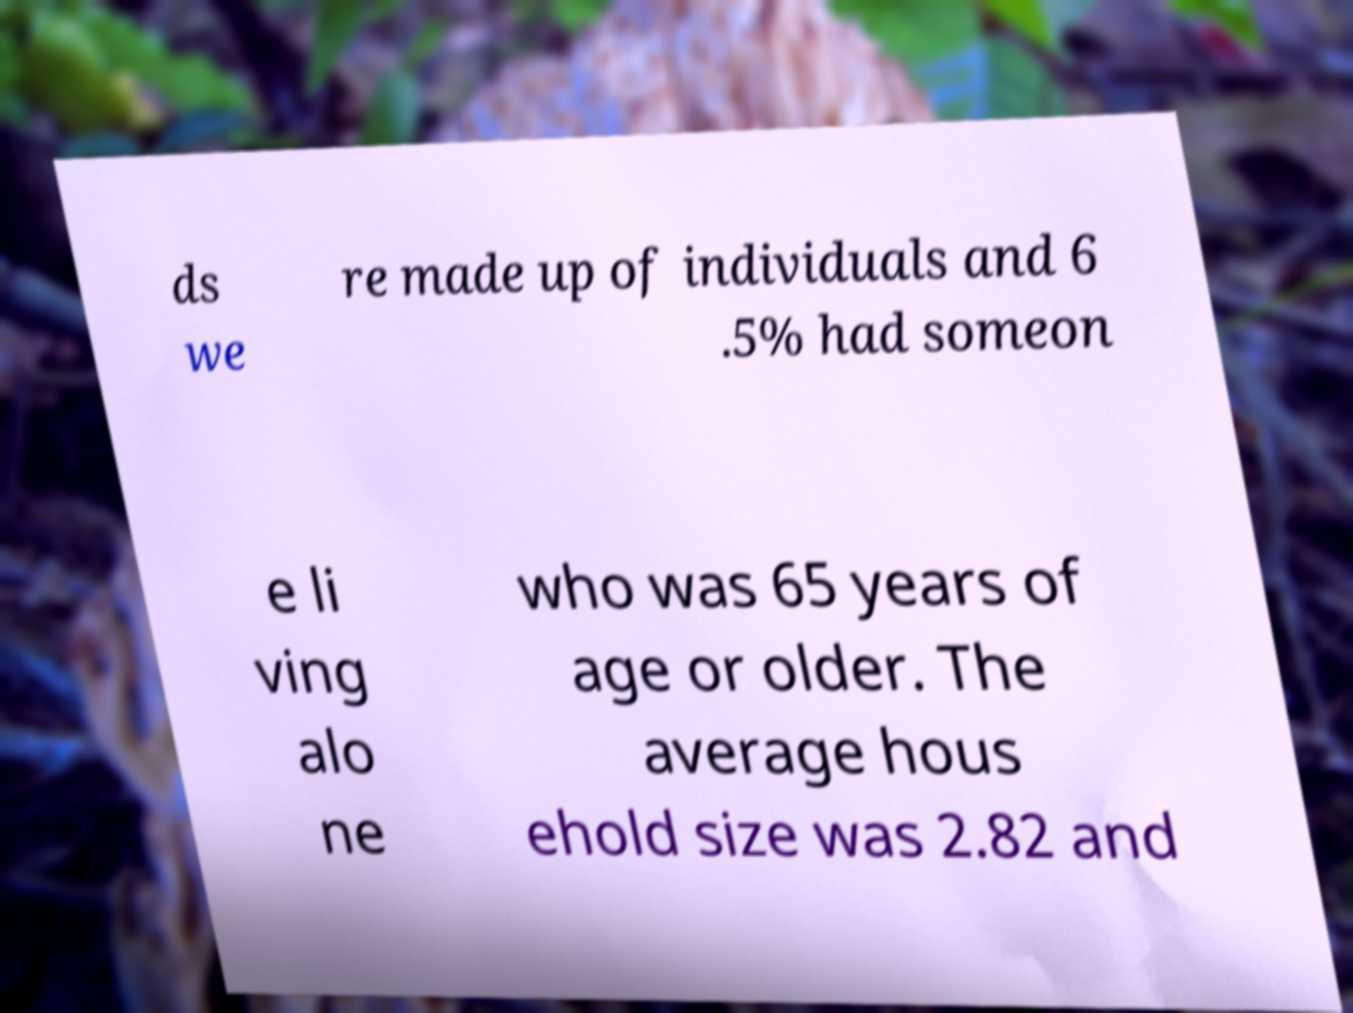Can you read and provide the text displayed in the image?This photo seems to have some interesting text. Can you extract and type it out for me? ds we re made up of individuals and 6 .5% had someon e li ving alo ne who was 65 years of age or older. The average hous ehold size was 2.82 and 